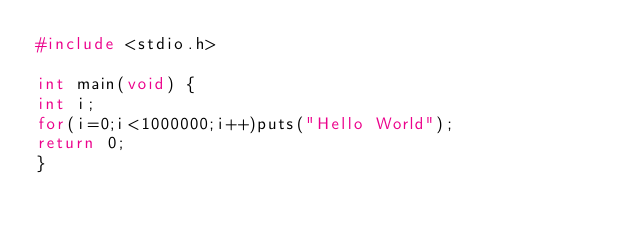<code> <loc_0><loc_0><loc_500><loc_500><_C_>#include <stdio.h>

int main(void) {
int i;
for(i=0;i<1000000;i++)puts("Hello World");
return 0;
}</code> 